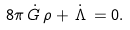Convert formula to latex. <formula><loc_0><loc_0><loc_500><loc_500>8 \pi \, \dot { G } \, \rho + \, \dot { \Lambda } \, = 0 .</formula> 